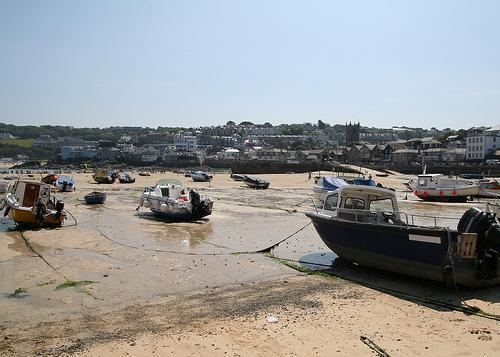Question: how many boats are shown?
Choices:
A. 8.
B. 15.
C. 7.
D. 6.
Answer with the letter. Answer: B Question: how many people are shown?
Choices:
A. 2.
B. 3.
C. 0.
D. 4.
Answer with the letter. Answer: C 